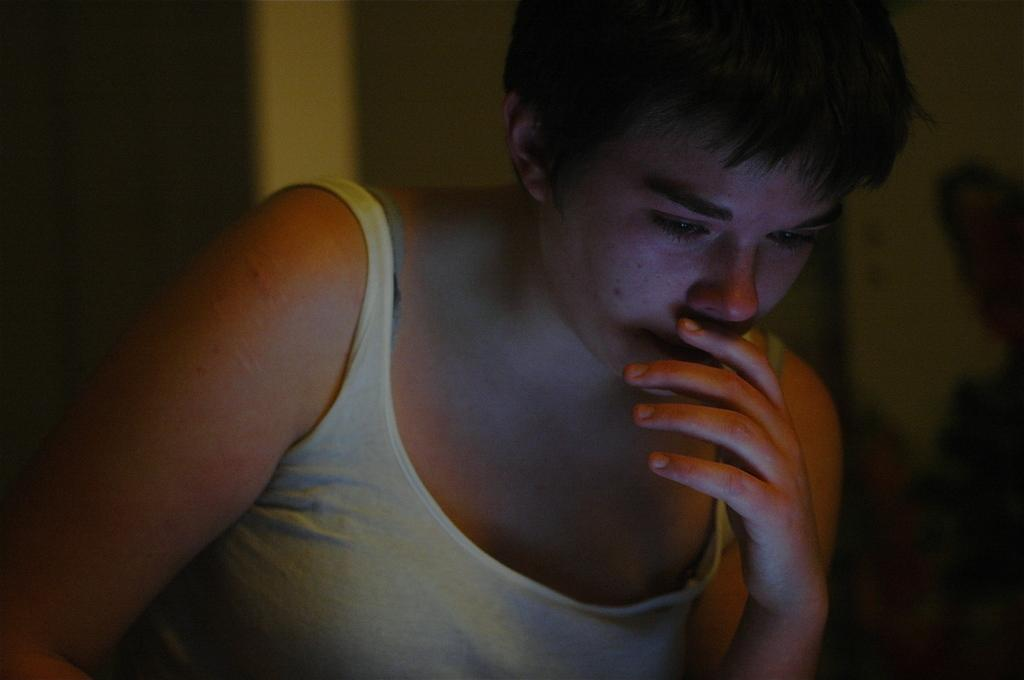What is the main subject of the image? There is a person in the image. What is the person wearing? The person is wearing a white vest. Can you describe the background of the image? The background of the image is blurred. What type of pollution can be seen in the image? There is no pollution visible in the image; it only features a person wearing a white vest with a blurred background. 